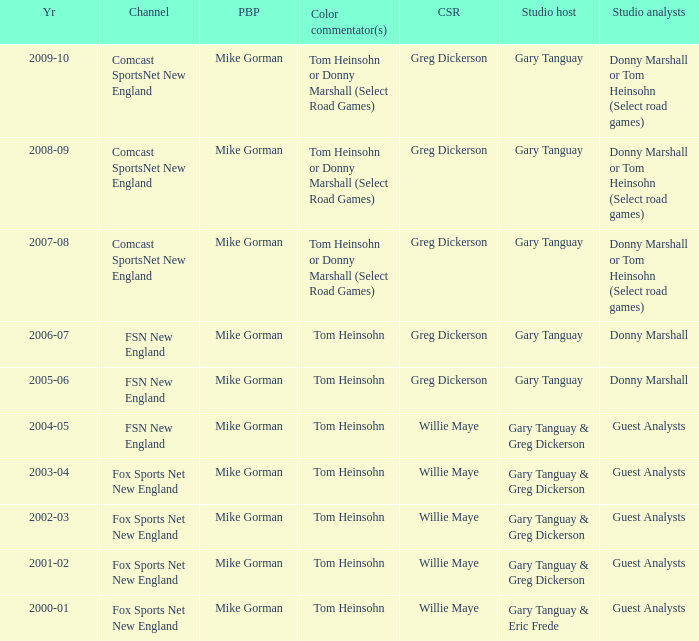Which Courtside reporter has a Channel of fsn new england in 2006-07? Greg Dickerson. 